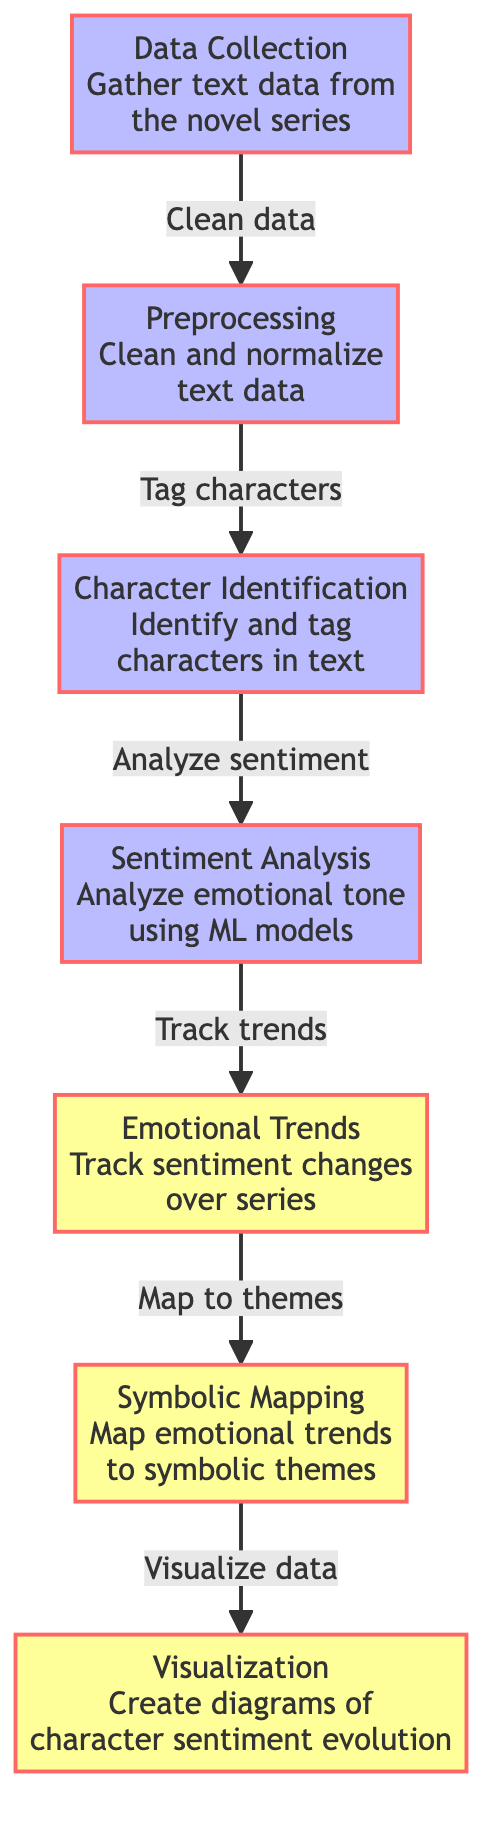What is the first step in the diagram? The first step is labeled "Data Collection" which indicates that the process begins with gathering text data from the novel series.
Answer: Data Collection How many output nodes are in the diagram? There are three output nodes: "Emotional Trends," "Symbolic Mapping," and "Visualization."
Answer: Three What is the purpose of the "Sentiment Analysis" node? The purpose of this node is to analyze the emotional tone of the text using machine learning models, which helps in understanding character emotions.
Answer: Analyze emotional tone Which node follows the "Character Identification" node? The "Sentiment Analysis" node follows the "Character Identification" node in the flowchart.
Answer: Sentiment Analysis What connects "Emotional Trends" to "Symbolic Mapping"? The connection is based on analyzing and tracking the sentiment changes over the series and mapping them to symbolic themes.
Answer: Track trends What kind of data is gathered in the "Data Collection" step? The data gathered consists of text data from the novel series, which serves as the foundational input for the subsequent analysis.
Answer: Text data What does the "Visualization" step create? The "Visualization" step creates diagrams that depict the evolution of character sentiment over the course of the series, allowing for a visual representation of the emotional journey.
Answer: Diagrams What does the "Preprocessing" node handle? The "Preprocessing" node handles the cleaning and normalization of the text data to prepare it for analysis in subsequent steps.
Answer: Clean and normalize What is the relationship between "Emotional Trends" and "Symbolic Mapping"? The relationship is that emotional trends are tracked and then mapped to symbolic themes, creating connections between character sentiment and broader themes in the narrative.
Answer: Track and map themes 